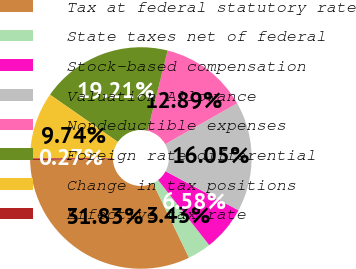Convert chart to OTSL. <chart><loc_0><loc_0><loc_500><loc_500><pie_chart><fcel>Tax at federal statutory rate<fcel>State taxes net of federal<fcel>Stock-based compensation<fcel>Valuation Allowance<fcel>Nondeductible expenses<fcel>Foreign rate differential<fcel>Change in tax positions<fcel>Effective tax rate<nl><fcel>31.83%<fcel>3.43%<fcel>6.58%<fcel>16.05%<fcel>12.89%<fcel>19.21%<fcel>9.74%<fcel>0.27%<nl></chart> 